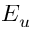<formula> <loc_0><loc_0><loc_500><loc_500>E _ { u }</formula> 